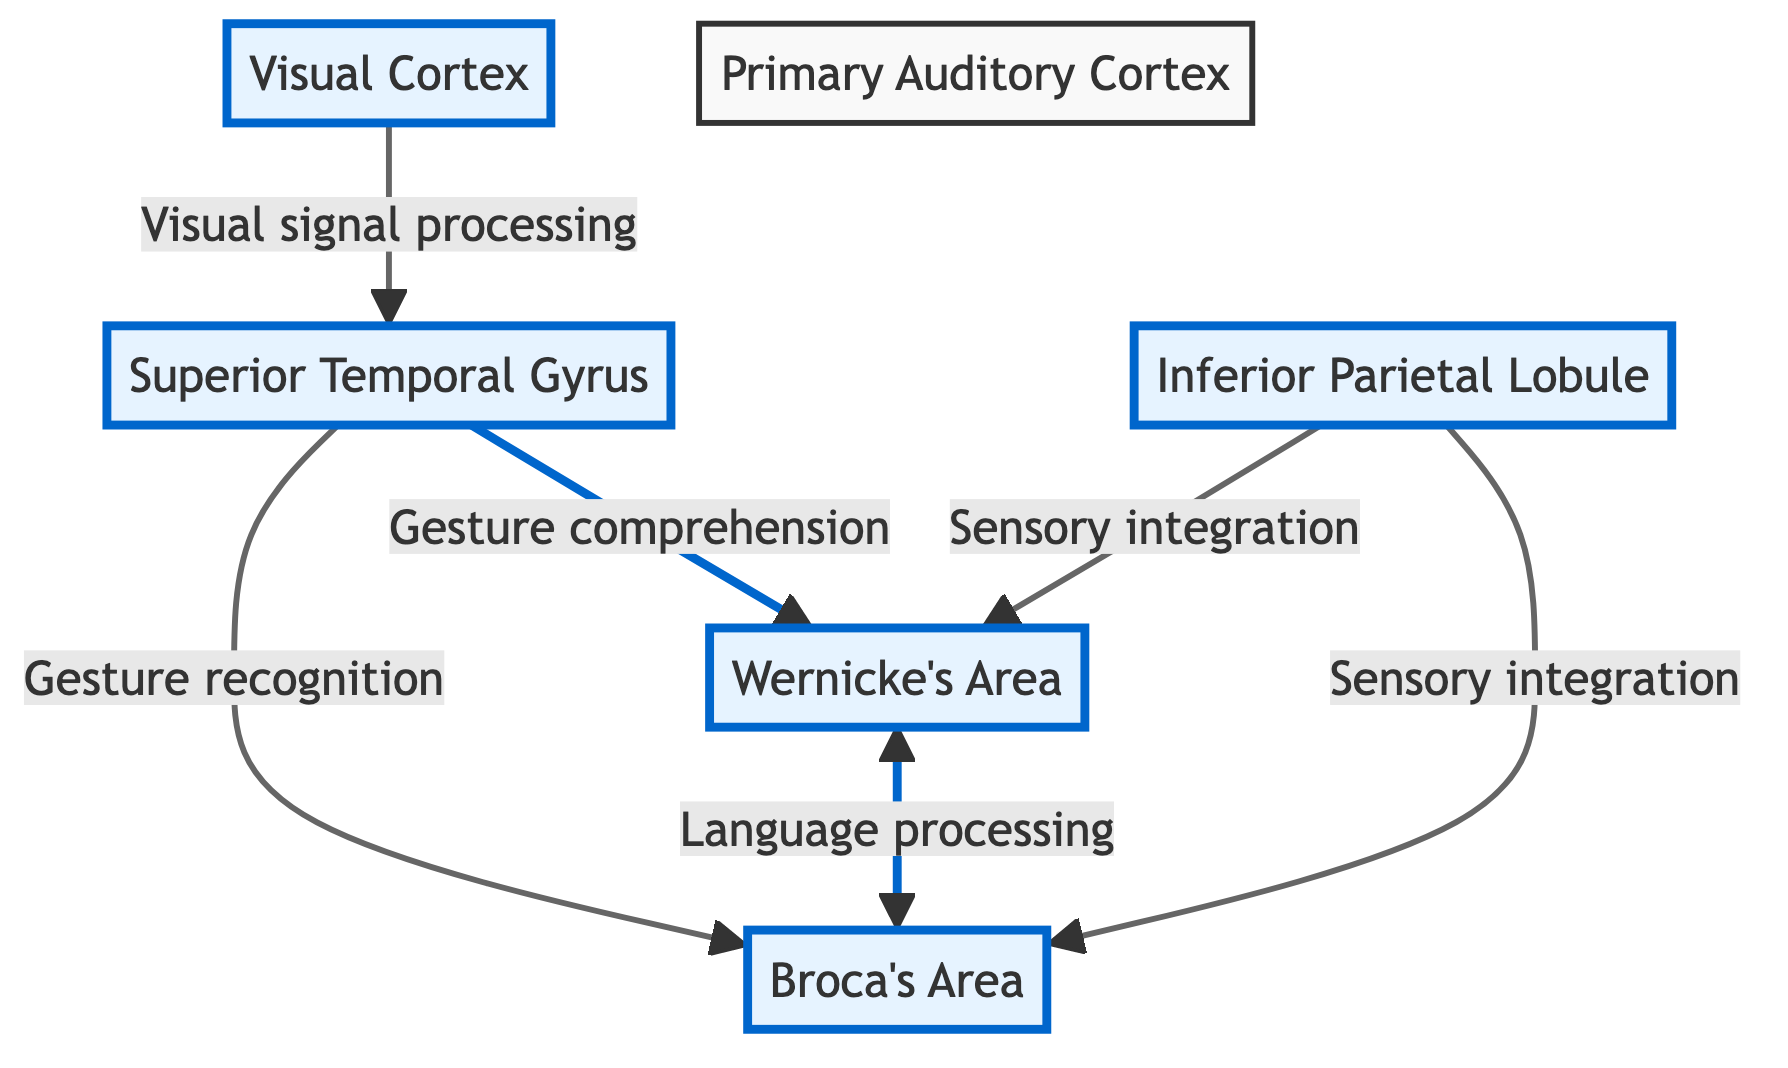What are the main brain regions involved in sign language processing? The diagram shows five main brain regions involved in sign language processing: Visual Cortex, Primary Auditory Cortex, Superior Temporal Gyrus, Broca's Area, and Wernicke's Area.
Answer: Visual Cortex, Primary Auditory Cortex, Superior Temporal Gyrus, Broca's Area, Wernicke's Area How is visual information processed in the brain for sign language? According to the diagram, visual information is processed in the Visual Cortex, which sends visual signals to the Superior Temporal Gyrus for further processing.
Answer: Visual Cortex Which area is responsible for gesture recognition? The diagram indicates that the Superior Temporal Gyrus is responsible for gesture recognition, as it receives processed visual signals from the Visual Cortex.
Answer: Superior Temporal Gyrus What is the relationship between Wernicke's Area and Broca's Area? The diagram depicts a bidirectional link between Wernicke's Area and Broca's Area, indicating that both areas are connected and communicate with each other for language processing.
Answer: Bidirectional communication How many sensory integration connections lead to Broca's Area? The diagram shows that there are two sensory integration connections leading to Broca's Area: one from the Inferior Parietal Lobule and another from the Superior Temporal Gyrus.
Answer: Two connections Which area does the Primary Auditory Cortex connect to? The diagram indicates that the Primary Auditory Cortex does not have direct connections to the other areas involved in sign language processing, depicting it as a passive or default node.
Answer: None Which area is involved in both gesture comprehension and language processing? According to the diagram, the Superior Temporal Gyrus is involved in gesture comprehension as it connects to Wernicke's Area for language processing.
Answer: Superior Temporal Gyrus What kind of processing is the Inferior Parietal Lobule involved in? The diagram specifies that the Inferior Parietal Lobule is involved in sensory integration, connecting to both Broca's Area and Wernicke's Area.
Answer: Sensory integration What signal processing pathway does the visual signal follow? The pathway begins at the Visual Cortex, which processes visual signals and then transmits them to the Superior Temporal Gyrus, where gesture recognition and comprehension occur.
Answer: Visual Cortex to Superior Temporal Gyrus 